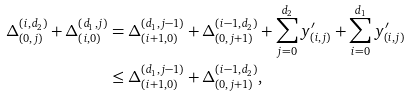Convert formula to latex. <formula><loc_0><loc_0><loc_500><loc_500>\Delta _ { ( 0 , j ) } ^ { ( i , d _ { 2 } ) } + \Delta _ { ( i , 0 ) } ^ { ( d _ { 1 } , j ) } & = \Delta _ { ( i + 1 , 0 ) } ^ { ( d _ { 1 } , j - 1 ) } + \Delta _ { ( 0 , j + 1 ) } ^ { ( i - 1 , d _ { 2 } ) } + \sum _ { j = 0 } ^ { d _ { 2 } } y _ { ( i , j ) } ^ { \prime } + \sum _ { i = 0 } ^ { d _ { 1 } } y _ { ( i , j ) } ^ { \prime } \\ & \leq \Delta _ { ( i + 1 , 0 ) } ^ { ( d _ { 1 } , j - 1 ) } + \Delta _ { ( 0 , j + 1 ) } ^ { ( i - 1 , d _ { 2 } ) } ,</formula> 